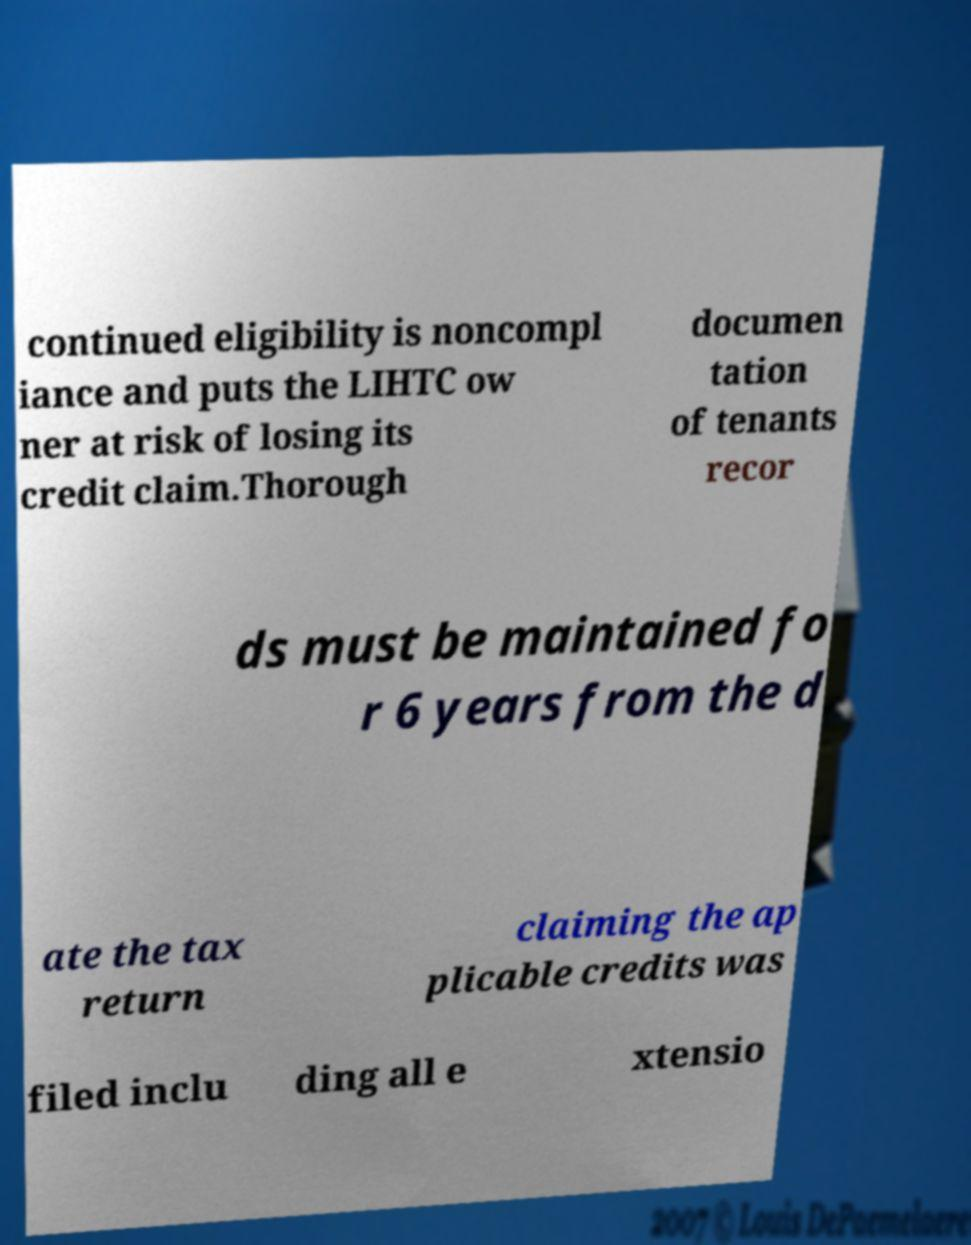Please identify and transcribe the text found in this image. continued eligibility is noncompl iance and puts the LIHTC ow ner at risk of losing its credit claim.Thorough documen tation of tenants recor ds must be maintained fo r 6 years from the d ate the tax return claiming the ap plicable credits was filed inclu ding all e xtensio 